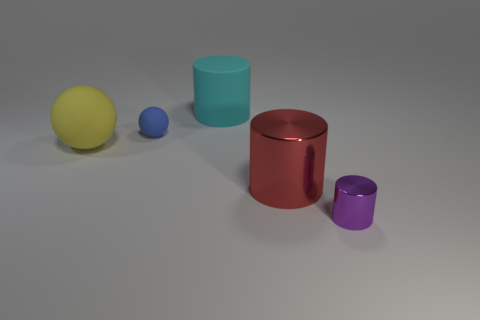What is the color of the tiny thing that is in front of the metal cylinder that is behind the small purple metal cylinder?
Your response must be concise. Purple. Is there a blue sphere?
Offer a terse response. Yes. Do the big yellow object and the cyan matte object have the same shape?
Provide a succinct answer. No. There is a matte thing that is to the right of the blue matte ball; what number of large red metal cylinders are behind it?
Your answer should be compact. 0. How many shiny cylinders are in front of the red cylinder and behind the tiny metal cylinder?
Provide a short and direct response. 0. What number of things are purple rubber things or cylinders that are in front of the big metal object?
Your answer should be very brief. 1. What size is the cyan thing that is made of the same material as the yellow object?
Give a very brief answer. Large. There is a large object that is behind the matte ball that is in front of the small blue rubber sphere; what shape is it?
Your response must be concise. Cylinder. How many gray things are either large cylinders or cylinders?
Offer a very short reply. 0. Is there a big cyan object left of the large yellow matte ball in front of the big cylinder behind the large red cylinder?
Your answer should be very brief. No. 